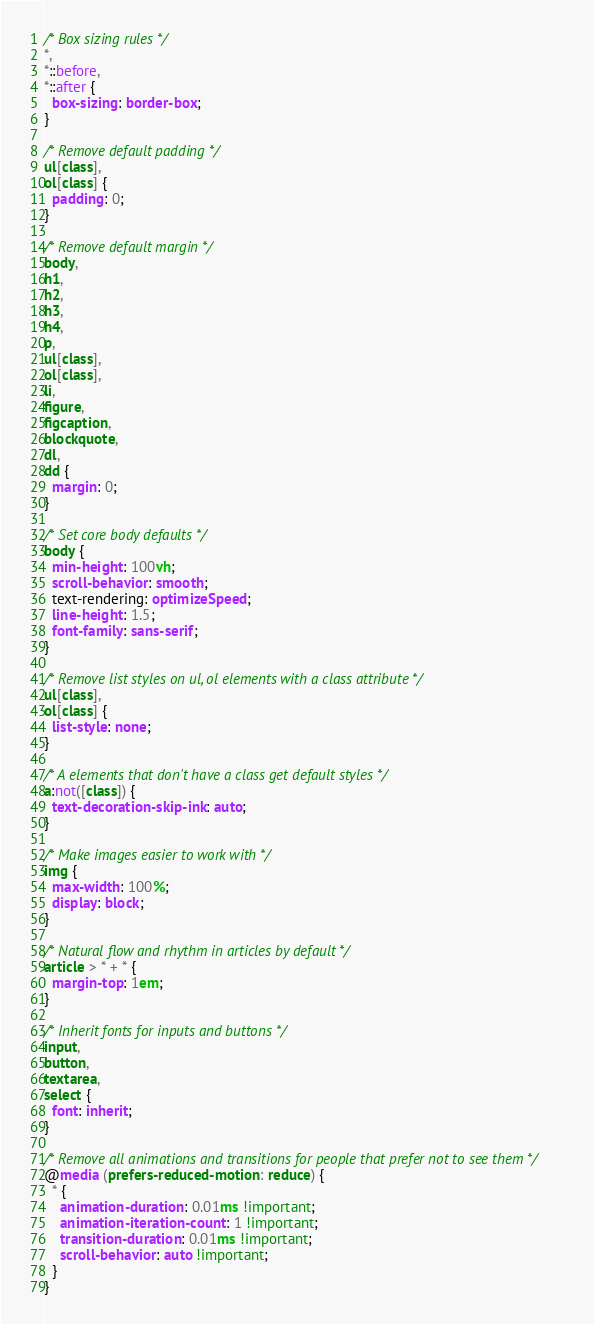<code> <loc_0><loc_0><loc_500><loc_500><_CSS_>/* Box sizing rules */
*,
*::before,
*::after {
  box-sizing: border-box;
}

/* Remove default padding */
ul[class],
ol[class] {
  padding: 0;
}

/* Remove default margin */
body,
h1,
h2,
h3,
h4,
p,
ul[class],
ol[class],
li,
figure,
figcaption,
blockquote,
dl,
dd {
  margin: 0;
}

/* Set core body defaults */
body {
  min-height: 100vh;
  scroll-behavior: smooth;
  text-rendering: optimizeSpeed;
  line-height: 1.5;
  font-family: sans-serif;
}

/* Remove list styles on ul, ol elements with a class attribute */
ul[class],
ol[class] {
  list-style: none;
}

/* A elements that don't have a class get default styles */
a:not([class]) {
  text-decoration-skip-ink: auto;
}

/* Make images easier to work with */
img {
  max-width: 100%;
  display: block;
}

/* Natural flow and rhythm in articles by default */
article > * + * {
  margin-top: 1em;
}

/* Inherit fonts for inputs and buttons */
input,
button,
textarea,
select {
  font: inherit;
}

/* Remove all animations and transitions for people that prefer not to see them */
@media (prefers-reduced-motion: reduce) {
  * {
    animation-duration: 0.01ms !important;
    animation-iteration-count: 1 !important;
    transition-duration: 0.01ms !important;
    scroll-behavior: auto !important;
  }
}</code> 